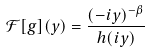<formula> <loc_0><loc_0><loc_500><loc_500>\mathcal { F } [ g ] ( y ) = \frac { ( - i y ) ^ { - \beta } } { h ( i y ) }</formula> 